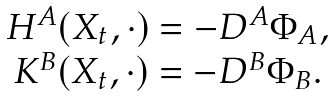Convert formula to latex. <formula><loc_0><loc_0><loc_500><loc_500>\begin{array} { c } H ^ { A } ( X _ { t } , \cdot ) = - D ^ { A } \Phi _ { A } , \\ K ^ { B } ( X _ { t } , \cdot ) = - D ^ { B } \Phi _ { B } . \end{array}</formula> 